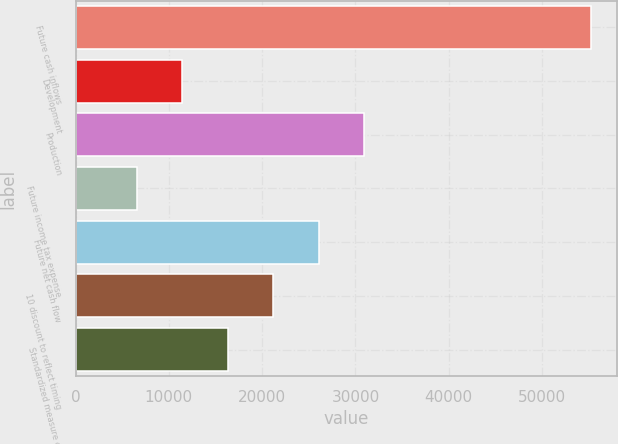Convert chart to OTSL. <chart><loc_0><loc_0><loc_500><loc_500><bar_chart><fcel>Future cash inflows<fcel>Development<fcel>Production<fcel>Future income tax expense<fcel>Future net cash flow<fcel>10 discount to reflect timing<fcel>Standardized measure of<nl><fcel>55297<fcel>11417.5<fcel>30919.5<fcel>6542<fcel>26044<fcel>21168.5<fcel>16293<nl></chart> 